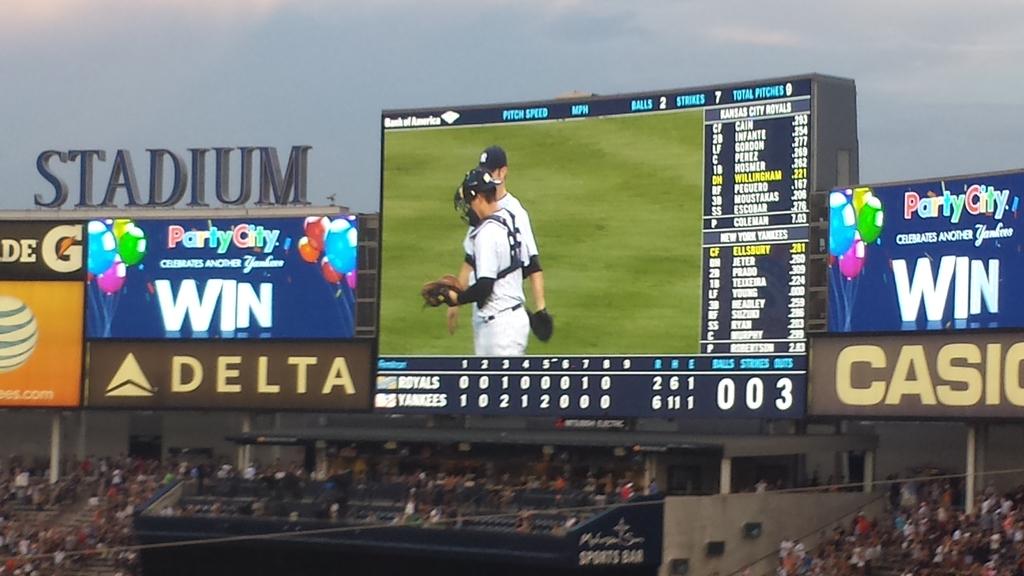What game is this?
Give a very brief answer. Baseball. What team is winning this game?
Offer a terse response. Yankees. 